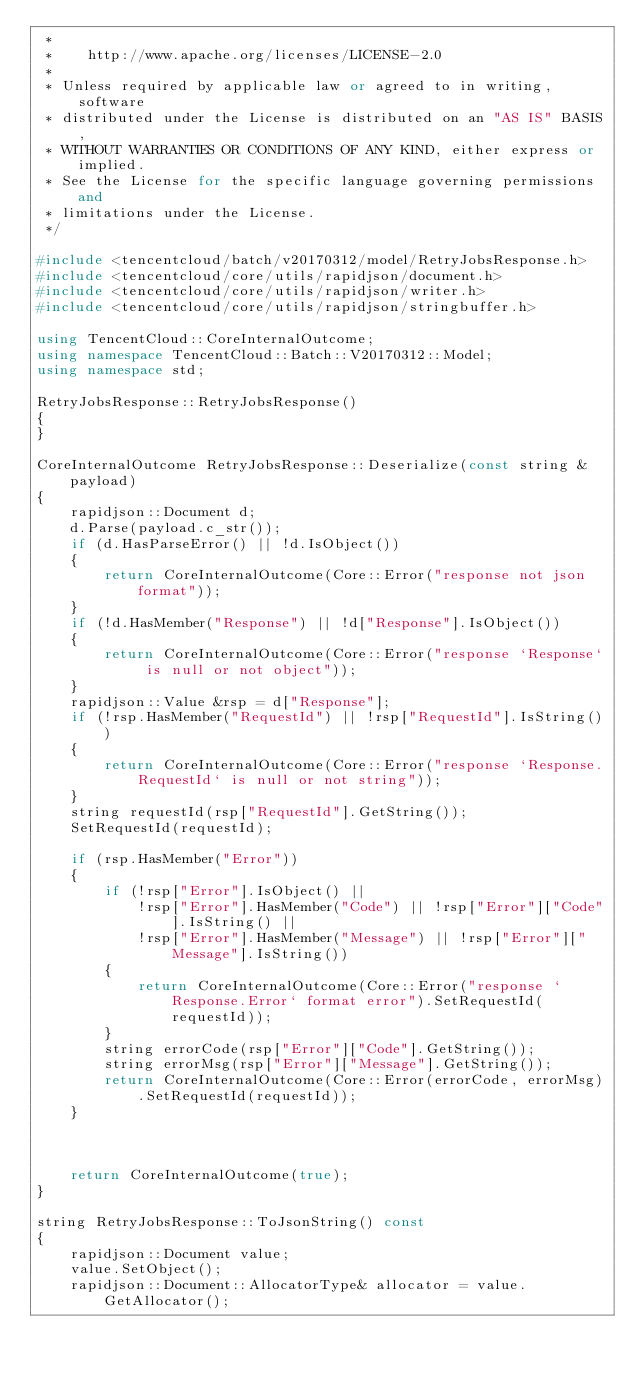Convert code to text. <code><loc_0><loc_0><loc_500><loc_500><_C++_> *
 *    http://www.apache.org/licenses/LICENSE-2.0
 *
 * Unless required by applicable law or agreed to in writing, software
 * distributed under the License is distributed on an "AS IS" BASIS,
 * WITHOUT WARRANTIES OR CONDITIONS OF ANY KIND, either express or implied.
 * See the License for the specific language governing permissions and
 * limitations under the License.
 */

#include <tencentcloud/batch/v20170312/model/RetryJobsResponse.h>
#include <tencentcloud/core/utils/rapidjson/document.h>
#include <tencentcloud/core/utils/rapidjson/writer.h>
#include <tencentcloud/core/utils/rapidjson/stringbuffer.h>

using TencentCloud::CoreInternalOutcome;
using namespace TencentCloud::Batch::V20170312::Model;
using namespace std;

RetryJobsResponse::RetryJobsResponse()
{
}

CoreInternalOutcome RetryJobsResponse::Deserialize(const string &payload)
{
    rapidjson::Document d;
    d.Parse(payload.c_str());
    if (d.HasParseError() || !d.IsObject())
    {
        return CoreInternalOutcome(Core::Error("response not json format"));
    }
    if (!d.HasMember("Response") || !d["Response"].IsObject())
    {
        return CoreInternalOutcome(Core::Error("response `Response` is null or not object"));
    }
    rapidjson::Value &rsp = d["Response"];
    if (!rsp.HasMember("RequestId") || !rsp["RequestId"].IsString())
    {
        return CoreInternalOutcome(Core::Error("response `Response.RequestId` is null or not string"));
    }
    string requestId(rsp["RequestId"].GetString());
    SetRequestId(requestId);

    if (rsp.HasMember("Error"))
    {
        if (!rsp["Error"].IsObject() ||
            !rsp["Error"].HasMember("Code") || !rsp["Error"]["Code"].IsString() ||
            !rsp["Error"].HasMember("Message") || !rsp["Error"]["Message"].IsString())
        {
            return CoreInternalOutcome(Core::Error("response `Response.Error` format error").SetRequestId(requestId));
        }
        string errorCode(rsp["Error"]["Code"].GetString());
        string errorMsg(rsp["Error"]["Message"].GetString());
        return CoreInternalOutcome(Core::Error(errorCode, errorMsg).SetRequestId(requestId));
    }



    return CoreInternalOutcome(true);
}

string RetryJobsResponse::ToJsonString() const
{
    rapidjson::Document value;
    value.SetObject();
    rapidjson::Document::AllocatorType& allocator = value.GetAllocator();
</code> 